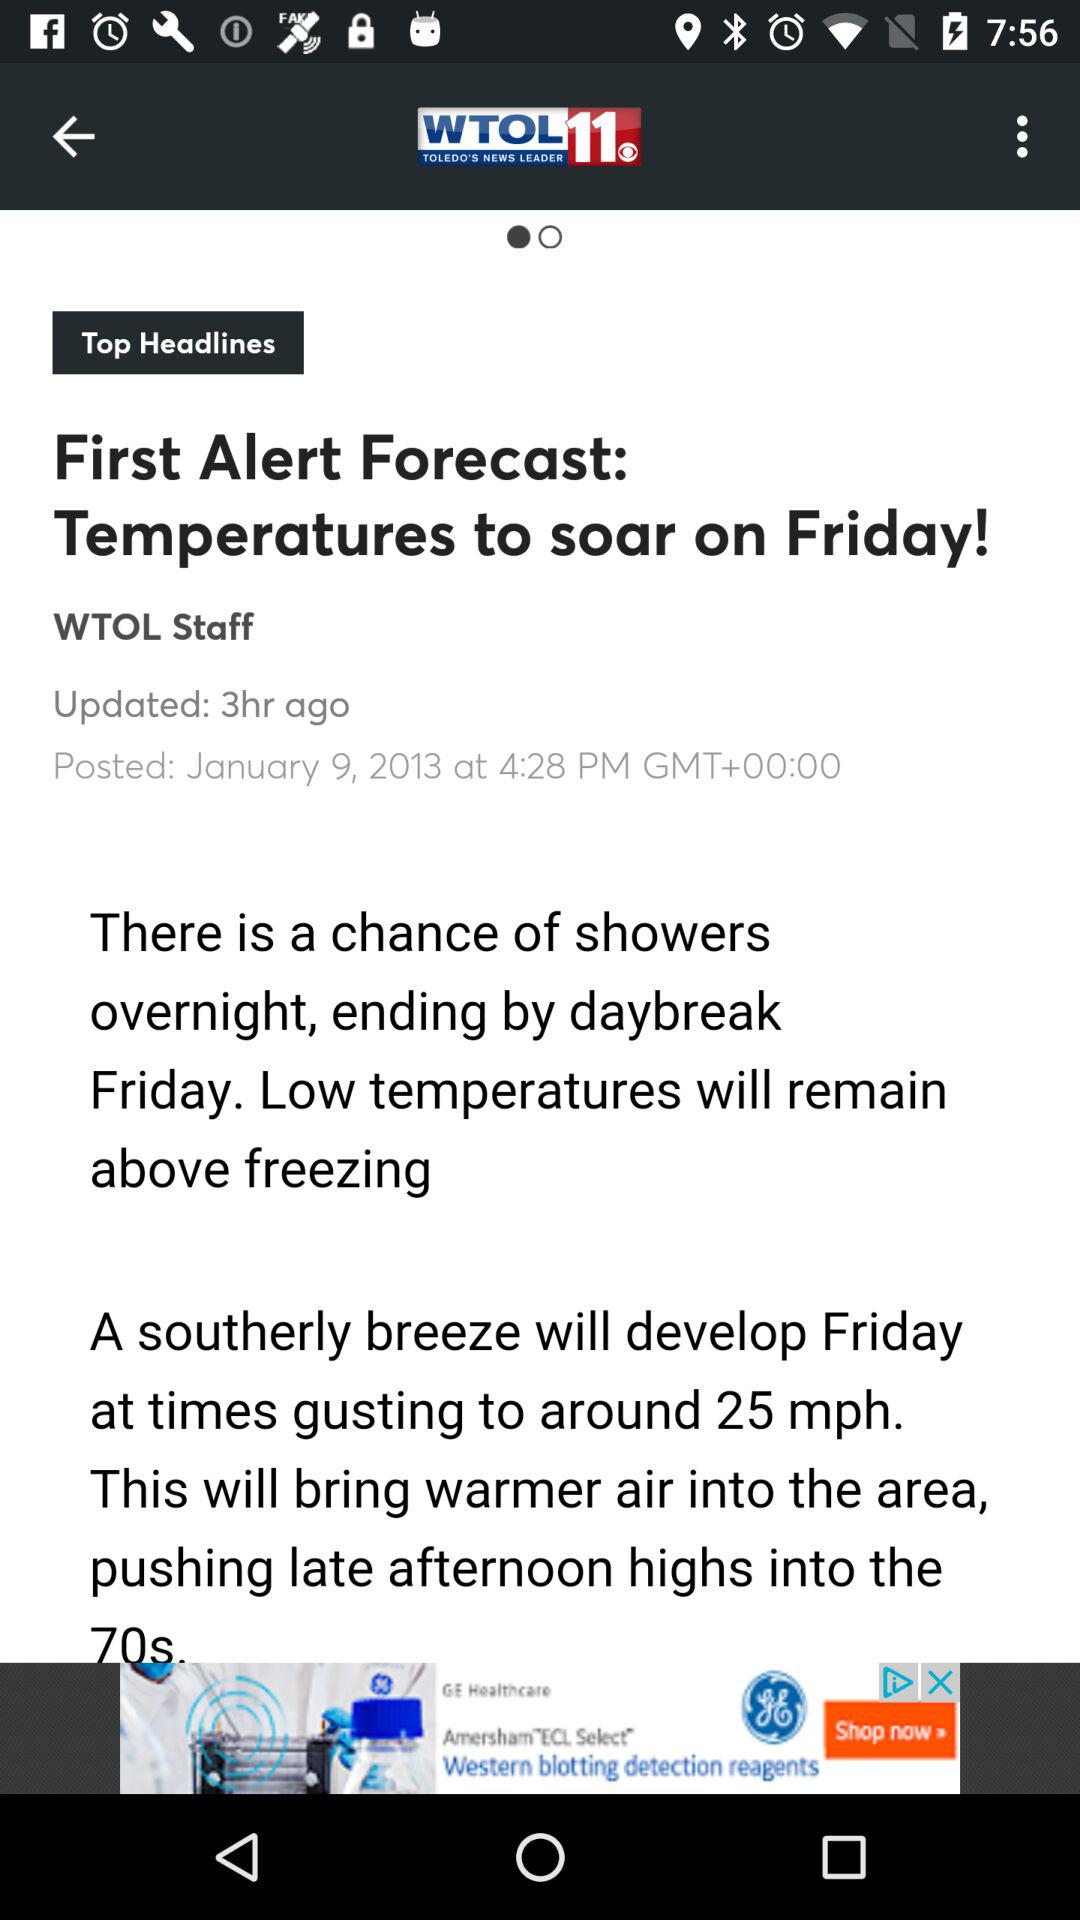How many hours ago was the article posted?
Answer the question using a single word or phrase. 3 